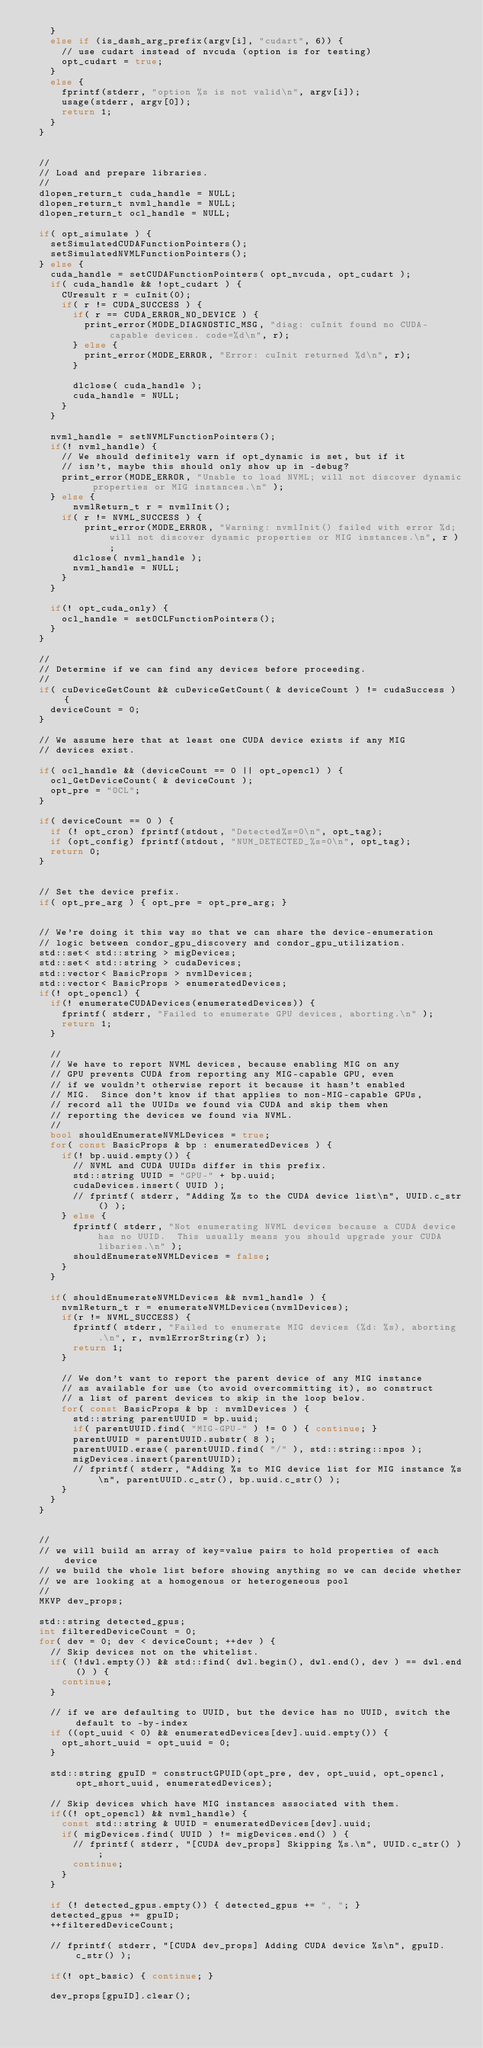Convert code to text. <code><loc_0><loc_0><loc_500><loc_500><_C++_>		}
		else if (is_dash_arg_prefix(argv[i], "cudart", 6)) {
			// use cudart instead of nvcuda (option is for testing)
			opt_cudart = true;
		}
		else {
			fprintf(stderr, "option %s is not valid\n", argv[i]);
			usage(stderr, argv[0]);
			return 1;
		}
	}


	//
	// Load and prepare libraries.
	//
	dlopen_return_t cuda_handle = NULL;
	dlopen_return_t nvml_handle = NULL;
	dlopen_return_t ocl_handle = NULL;

	if( opt_simulate ) {
		setSimulatedCUDAFunctionPointers();
		setSimulatedNVMLFunctionPointers();
	} else {
		cuda_handle = setCUDAFunctionPointers( opt_nvcuda, opt_cudart );
		if( cuda_handle && !opt_cudart ) {
			CUresult r = cuInit(0);
			if( r != CUDA_SUCCESS ) {
				if( r == CUDA_ERROR_NO_DEVICE ) {
					print_error(MODE_DIAGNOSTIC_MSG, "diag: cuInit found no CUDA-capable devices. code=%d\n", r);
				} else {
					print_error(MODE_ERROR, "Error: cuInit returned %d\n", r);
				}

				dlclose( cuda_handle );
				cuda_handle = NULL;
			}
		}

		nvml_handle = setNVMLFunctionPointers();
		if(! nvml_handle) {
			// We should definitely warn if opt_dynamic is set, but if it
			// isn't, maybe this should only show up in -debug?
			print_error(MODE_ERROR, "Unable to load NVML; will not discover dynamic properties or MIG instances.\n" );
		} else {
		    nvmlReturn_t r = nvmlInit();
			if( r != NVML_SUCCESS ) {
			    print_error(MODE_ERROR, "Warning: nvmlInit() failed with error %d; will not discover dynamic properties or MIG instances.\n", r );
				dlclose( nvml_handle );
				nvml_handle = NULL;
			}
		}

		if(! opt_cuda_only) {
			ocl_handle = setOCLFunctionPointers();
		}
	}

	//
	// Determine if we can find any devices before proceeding.
	//
	if( cuDeviceGetCount && cuDeviceGetCount( & deviceCount ) != cudaSuccess ) {
		deviceCount = 0;
	}

	// We assume here that at least one CUDA device exists if any MIG
	// devices exist.

	if( ocl_handle && (deviceCount == 0 || opt_opencl) ) {
		ocl_GetDeviceCount( & deviceCount );
		opt_pre = "OCL";
	}

	if( deviceCount == 0 ) {
		if (! opt_cron) fprintf(stdout, "Detected%s=0\n", opt_tag);
		if (opt_config) fprintf(stdout, "NUM_DETECTED_%s=0\n", opt_tag);
		return 0;
	}


	// Set the device prefix.
	if( opt_pre_arg ) { opt_pre = opt_pre_arg; }


	// We're doing it this way so that we can share the device-enumeration
	// logic between condor_gpu_discovery and condor_gpu_utilization.
	std::set< std::string > migDevices;
	std::set< std::string > cudaDevices;
	std::vector< BasicProps > nvmlDevices;
	std::vector< BasicProps > enumeratedDevices;
	if(! opt_opencl) {
		if(! enumerateCUDADevices(enumeratedDevices)) {
			fprintf( stderr, "Failed to enumerate GPU devices, aborting.\n" );
			return 1;
		}

		//
		// We have to report NVML devices, because enabling MIG on any
		// GPU prevents CUDA from reporting any MIG-capable GPU, even
		// if we wouldn't otherwise report it because it hasn't enabled
		// MIG.  Since don't know if that applies to non-MIG-capable GPUs,
		// record all the UUIDs we found via CUDA and skip them when
		// reporting the devices we found via NVML.
		//
		bool shouldEnumerateNVMLDevices = true;
		for( const BasicProps & bp : enumeratedDevices ) {
			if(! bp.uuid.empty()) {
				// NVML and CUDA UUIDs differ in this prefix.
				std::string UUID = "GPU-" + bp.uuid;
				cudaDevices.insert( UUID );
				// fprintf( stderr, "Adding %s to the CUDA device list\n", UUID.c_str() );
			} else {
				fprintf( stderr, "Not enumerating NVML devices because a CUDA device has no UUID.  This usually means you should upgrade your CUDA libaries.\n" );
				shouldEnumerateNVMLDevices = false;
			}
		}

		if( shouldEnumerateNVMLDevices && nvml_handle ) {
			nvmlReturn_t r = enumerateNVMLDevices(nvmlDevices);
			if(r != NVML_SUCCESS) {
				fprintf( stderr, "Failed to enumerate MIG devices (%d: %s), aborting.\n", r, nvmlErrorString(r) );
				return 1;
			}

			// We don't want to report the parent device of any MIG instance
			// as available for use (to avoid overcommitting it), so construct
			// a list of parent devices to skip in the loop below.
			for( const BasicProps & bp : nvmlDevices ) {
				std::string parentUUID = bp.uuid;
				if( parentUUID.find( "MIG-GPU-" ) != 0 ) { continue; }
				parentUUID = parentUUID.substr( 8 );
				parentUUID.erase( parentUUID.find( "/" ), std::string::npos );
				migDevices.insert(parentUUID);
				// fprintf( stderr, "Adding %s to MIG device list for MIG instance %s\n", parentUUID.c_str(), bp.uuid.c_str() );
			}
		}
	}


	//
	// we will build an array of key=value pairs to hold properties of each device
	// we build the whole list before showing anything so we can decide whether
	// we are looking at a homogenous or heterogeneous pool
	//
	MKVP dev_props;

	std::string detected_gpus;
	int filteredDeviceCount = 0;
	for( dev = 0; dev < deviceCount; ++dev ) {
		// Skip devices not on the whitelist.
		if( (!dwl.empty()) && std::find( dwl.begin(), dwl.end(), dev ) == dwl.end() ) {
			continue;
		}

		// if we are defaulting to UUID, but the device has no UUID, switch the default to -by-index
		if ((opt_uuid < 0) && enumeratedDevices[dev].uuid.empty()) {
			opt_short_uuid = opt_uuid = 0;
		}

		std::string gpuID = constructGPUID(opt_pre, dev, opt_uuid, opt_opencl, opt_short_uuid, enumeratedDevices);

		// Skip devices which have MIG instances associated with them.
		if((! opt_opencl) && nvml_handle) {
			const std::string & UUID = enumeratedDevices[dev].uuid;
			if( migDevices.find( UUID ) != migDevices.end() ) {
				// fprintf( stderr, "[CUDA dev_props] Skipping %s.\n", UUID.c_str() );
				continue;
			}
		}

		if (! detected_gpus.empty()) { detected_gpus += ", "; }
		detected_gpus += gpuID;
		++filteredDeviceCount;

		// fprintf( stderr, "[CUDA dev_props] Adding CUDA device %s\n", gpuID.c_str() );

		if(! opt_basic) { continue; }

		dev_props[gpuID].clear();</code> 